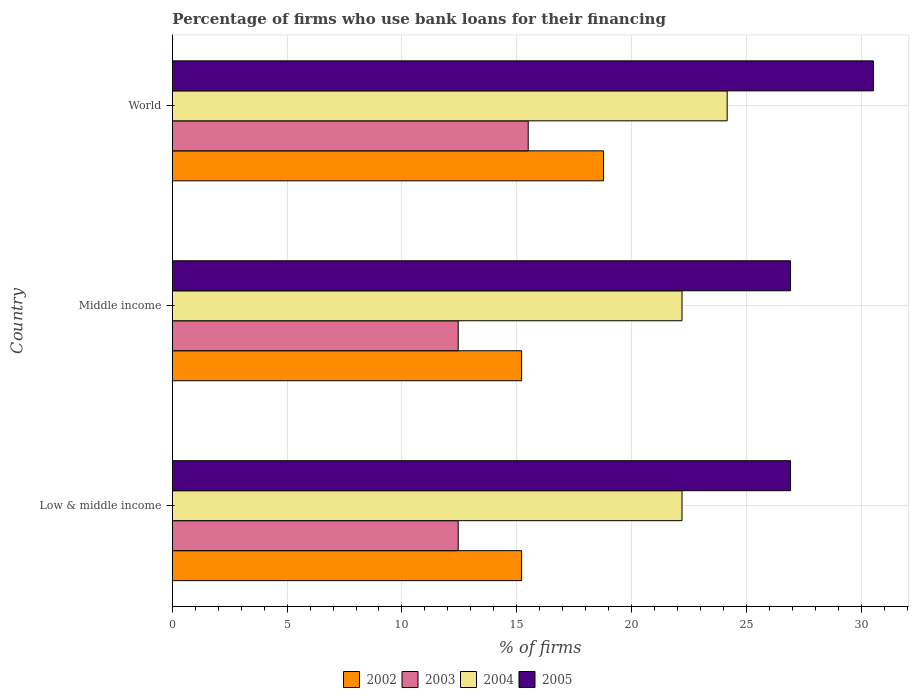How many different coloured bars are there?
Your response must be concise. 4. How many bars are there on the 1st tick from the top?
Your answer should be very brief. 4. How many bars are there on the 2nd tick from the bottom?
Keep it short and to the point. 4. What is the label of the 1st group of bars from the top?
Provide a succinct answer. World. What is the percentage of firms who use bank loans for their financing in 2003 in Low & middle income?
Provide a short and direct response. 12.45. Across all countries, what is the maximum percentage of firms who use bank loans for their financing in 2005?
Keep it short and to the point. 30.54. Across all countries, what is the minimum percentage of firms who use bank loans for their financing in 2002?
Make the answer very short. 15.21. In which country was the percentage of firms who use bank loans for their financing in 2005 maximum?
Your response must be concise. World. What is the total percentage of firms who use bank loans for their financing in 2005 in the graph?
Provide a short and direct response. 84.39. What is the difference between the percentage of firms who use bank loans for their financing in 2003 in Low & middle income and that in World?
Ensure brevity in your answer.  -3.05. What is the difference between the percentage of firms who use bank loans for their financing in 2004 in Middle income and the percentage of firms who use bank loans for their financing in 2003 in World?
Provide a succinct answer. 6.7. What is the average percentage of firms who use bank loans for their financing in 2002 per country?
Your answer should be compact. 16.4. What is the difference between the percentage of firms who use bank loans for their financing in 2002 and percentage of firms who use bank loans for their financing in 2004 in Middle income?
Make the answer very short. -6.99. In how many countries, is the percentage of firms who use bank loans for their financing in 2004 greater than 10 %?
Keep it short and to the point. 3. What is the ratio of the percentage of firms who use bank loans for their financing in 2003 in Middle income to that in World?
Your response must be concise. 0.8. Is the difference between the percentage of firms who use bank loans for their financing in 2002 in Low & middle income and Middle income greater than the difference between the percentage of firms who use bank loans for their financing in 2004 in Low & middle income and Middle income?
Offer a very short reply. No. What is the difference between the highest and the second highest percentage of firms who use bank loans for their financing in 2002?
Provide a short and direct response. 3.57. What is the difference between the highest and the lowest percentage of firms who use bank loans for their financing in 2002?
Ensure brevity in your answer.  3.57. Is the sum of the percentage of firms who use bank loans for their financing in 2004 in Middle income and World greater than the maximum percentage of firms who use bank loans for their financing in 2005 across all countries?
Your response must be concise. Yes. Is it the case that in every country, the sum of the percentage of firms who use bank loans for their financing in 2004 and percentage of firms who use bank loans for their financing in 2003 is greater than the sum of percentage of firms who use bank loans for their financing in 2002 and percentage of firms who use bank loans for their financing in 2005?
Give a very brief answer. No. What does the 1st bar from the top in World represents?
Offer a very short reply. 2005. Are all the bars in the graph horizontal?
Give a very brief answer. Yes. Does the graph contain any zero values?
Give a very brief answer. No. Where does the legend appear in the graph?
Provide a succinct answer. Bottom center. How many legend labels are there?
Give a very brief answer. 4. What is the title of the graph?
Provide a short and direct response. Percentage of firms who use bank loans for their financing. What is the label or title of the X-axis?
Your answer should be compact. % of firms. What is the label or title of the Y-axis?
Give a very brief answer. Country. What is the % of firms in 2002 in Low & middle income?
Your answer should be very brief. 15.21. What is the % of firms in 2003 in Low & middle income?
Provide a short and direct response. 12.45. What is the % of firms in 2004 in Low & middle income?
Your answer should be very brief. 22.2. What is the % of firms of 2005 in Low & middle income?
Offer a terse response. 26.93. What is the % of firms in 2002 in Middle income?
Offer a terse response. 15.21. What is the % of firms in 2003 in Middle income?
Provide a short and direct response. 12.45. What is the % of firms of 2005 in Middle income?
Provide a short and direct response. 26.93. What is the % of firms in 2002 in World?
Your response must be concise. 18.78. What is the % of firms in 2004 in World?
Keep it short and to the point. 24.17. What is the % of firms in 2005 in World?
Provide a succinct answer. 30.54. Across all countries, what is the maximum % of firms of 2002?
Make the answer very short. 18.78. Across all countries, what is the maximum % of firms of 2003?
Offer a terse response. 15.5. Across all countries, what is the maximum % of firms of 2004?
Offer a terse response. 24.17. Across all countries, what is the maximum % of firms in 2005?
Offer a terse response. 30.54. Across all countries, what is the minimum % of firms of 2002?
Keep it short and to the point. 15.21. Across all countries, what is the minimum % of firms in 2003?
Provide a short and direct response. 12.45. Across all countries, what is the minimum % of firms of 2004?
Provide a short and direct response. 22.2. Across all countries, what is the minimum % of firms of 2005?
Offer a very short reply. 26.93. What is the total % of firms of 2002 in the graph?
Make the answer very short. 49.21. What is the total % of firms in 2003 in the graph?
Offer a terse response. 40.4. What is the total % of firms in 2004 in the graph?
Offer a very short reply. 68.57. What is the total % of firms of 2005 in the graph?
Ensure brevity in your answer.  84.39. What is the difference between the % of firms of 2002 in Low & middle income and that in Middle income?
Your answer should be compact. 0. What is the difference between the % of firms in 2002 in Low & middle income and that in World?
Provide a succinct answer. -3.57. What is the difference between the % of firms of 2003 in Low & middle income and that in World?
Your answer should be very brief. -3.05. What is the difference between the % of firms in 2004 in Low & middle income and that in World?
Provide a succinct answer. -1.97. What is the difference between the % of firms in 2005 in Low & middle income and that in World?
Ensure brevity in your answer.  -3.61. What is the difference between the % of firms in 2002 in Middle income and that in World?
Keep it short and to the point. -3.57. What is the difference between the % of firms of 2003 in Middle income and that in World?
Your response must be concise. -3.05. What is the difference between the % of firms of 2004 in Middle income and that in World?
Provide a succinct answer. -1.97. What is the difference between the % of firms of 2005 in Middle income and that in World?
Provide a succinct answer. -3.61. What is the difference between the % of firms of 2002 in Low & middle income and the % of firms of 2003 in Middle income?
Give a very brief answer. 2.76. What is the difference between the % of firms of 2002 in Low & middle income and the % of firms of 2004 in Middle income?
Your response must be concise. -6.99. What is the difference between the % of firms in 2002 in Low & middle income and the % of firms in 2005 in Middle income?
Provide a short and direct response. -11.72. What is the difference between the % of firms of 2003 in Low & middle income and the % of firms of 2004 in Middle income?
Your answer should be very brief. -9.75. What is the difference between the % of firms in 2003 in Low & middle income and the % of firms in 2005 in Middle income?
Ensure brevity in your answer.  -14.48. What is the difference between the % of firms of 2004 in Low & middle income and the % of firms of 2005 in Middle income?
Offer a terse response. -4.73. What is the difference between the % of firms in 2002 in Low & middle income and the % of firms in 2003 in World?
Offer a terse response. -0.29. What is the difference between the % of firms of 2002 in Low & middle income and the % of firms of 2004 in World?
Your answer should be very brief. -8.95. What is the difference between the % of firms in 2002 in Low & middle income and the % of firms in 2005 in World?
Make the answer very short. -15.33. What is the difference between the % of firms of 2003 in Low & middle income and the % of firms of 2004 in World?
Your answer should be compact. -11.72. What is the difference between the % of firms in 2003 in Low & middle income and the % of firms in 2005 in World?
Ensure brevity in your answer.  -18.09. What is the difference between the % of firms of 2004 in Low & middle income and the % of firms of 2005 in World?
Offer a terse response. -8.34. What is the difference between the % of firms of 2002 in Middle income and the % of firms of 2003 in World?
Keep it short and to the point. -0.29. What is the difference between the % of firms in 2002 in Middle income and the % of firms in 2004 in World?
Provide a succinct answer. -8.95. What is the difference between the % of firms of 2002 in Middle income and the % of firms of 2005 in World?
Provide a succinct answer. -15.33. What is the difference between the % of firms in 2003 in Middle income and the % of firms in 2004 in World?
Ensure brevity in your answer.  -11.72. What is the difference between the % of firms of 2003 in Middle income and the % of firms of 2005 in World?
Your answer should be compact. -18.09. What is the difference between the % of firms of 2004 in Middle income and the % of firms of 2005 in World?
Keep it short and to the point. -8.34. What is the average % of firms of 2002 per country?
Offer a terse response. 16.4. What is the average % of firms in 2003 per country?
Provide a short and direct response. 13.47. What is the average % of firms in 2004 per country?
Your answer should be compact. 22.86. What is the average % of firms of 2005 per country?
Offer a very short reply. 28.13. What is the difference between the % of firms in 2002 and % of firms in 2003 in Low & middle income?
Offer a very short reply. 2.76. What is the difference between the % of firms of 2002 and % of firms of 2004 in Low & middle income?
Your answer should be compact. -6.99. What is the difference between the % of firms in 2002 and % of firms in 2005 in Low & middle income?
Keep it short and to the point. -11.72. What is the difference between the % of firms in 2003 and % of firms in 2004 in Low & middle income?
Keep it short and to the point. -9.75. What is the difference between the % of firms in 2003 and % of firms in 2005 in Low & middle income?
Your answer should be very brief. -14.48. What is the difference between the % of firms in 2004 and % of firms in 2005 in Low & middle income?
Provide a short and direct response. -4.73. What is the difference between the % of firms in 2002 and % of firms in 2003 in Middle income?
Give a very brief answer. 2.76. What is the difference between the % of firms in 2002 and % of firms in 2004 in Middle income?
Make the answer very short. -6.99. What is the difference between the % of firms of 2002 and % of firms of 2005 in Middle income?
Provide a short and direct response. -11.72. What is the difference between the % of firms in 2003 and % of firms in 2004 in Middle income?
Offer a very short reply. -9.75. What is the difference between the % of firms of 2003 and % of firms of 2005 in Middle income?
Offer a very short reply. -14.48. What is the difference between the % of firms of 2004 and % of firms of 2005 in Middle income?
Ensure brevity in your answer.  -4.73. What is the difference between the % of firms of 2002 and % of firms of 2003 in World?
Give a very brief answer. 3.28. What is the difference between the % of firms in 2002 and % of firms in 2004 in World?
Provide a succinct answer. -5.39. What is the difference between the % of firms in 2002 and % of firms in 2005 in World?
Provide a short and direct response. -11.76. What is the difference between the % of firms of 2003 and % of firms of 2004 in World?
Provide a succinct answer. -8.67. What is the difference between the % of firms of 2003 and % of firms of 2005 in World?
Give a very brief answer. -15.04. What is the difference between the % of firms of 2004 and % of firms of 2005 in World?
Offer a very short reply. -6.37. What is the ratio of the % of firms of 2002 in Low & middle income to that in Middle income?
Your answer should be compact. 1. What is the ratio of the % of firms in 2003 in Low & middle income to that in Middle income?
Your answer should be compact. 1. What is the ratio of the % of firms of 2005 in Low & middle income to that in Middle income?
Provide a succinct answer. 1. What is the ratio of the % of firms in 2002 in Low & middle income to that in World?
Provide a succinct answer. 0.81. What is the ratio of the % of firms of 2003 in Low & middle income to that in World?
Give a very brief answer. 0.8. What is the ratio of the % of firms of 2004 in Low & middle income to that in World?
Provide a succinct answer. 0.92. What is the ratio of the % of firms of 2005 in Low & middle income to that in World?
Offer a terse response. 0.88. What is the ratio of the % of firms in 2002 in Middle income to that in World?
Your response must be concise. 0.81. What is the ratio of the % of firms in 2003 in Middle income to that in World?
Keep it short and to the point. 0.8. What is the ratio of the % of firms in 2004 in Middle income to that in World?
Your answer should be very brief. 0.92. What is the ratio of the % of firms in 2005 in Middle income to that in World?
Keep it short and to the point. 0.88. What is the difference between the highest and the second highest % of firms of 2002?
Ensure brevity in your answer.  3.57. What is the difference between the highest and the second highest % of firms of 2003?
Your answer should be compact. 3.05. What is the difference between the highest and the second highest % of firms in 2004?
Keep it short and to the point. 1.97. What is the difference between the highest and the second highest % of firms in 2005?
Provide a succinct answer. 3.61. What is the difference between the highest and the lowest % of firms in 2002?
Ensure brevity in your answer.  3.57. What is the difference between the highest and the lowest % of firms in 2003?
Offer a very short reply. 3.05. What is the difference between the highest and the lowest % of firms of 2004?
Ensure brevity in your answer.  1.97. What is the difference between the highest and the lowest % of firms in 2005?
Ensure brevity in your answer.  3.61. 